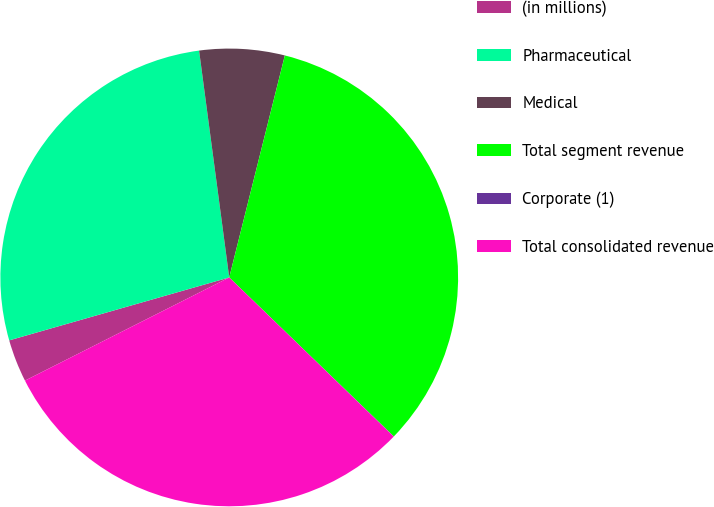<chart> <loc_0><loc_0><loc_500><loc_500><pie_chart><fcel>(in millions)<fcel>Pharmaceutical<fcel>Medical<fcel>Total segment revenue<fcel>Corporate (1)<fcel>Total consolidated revenue<nl><fcel>3.01%<fcel>27.33%<fcel>6.01%<fcel>33.32%<fcel>0.01%<fcel>30.32%<nl></chart> 